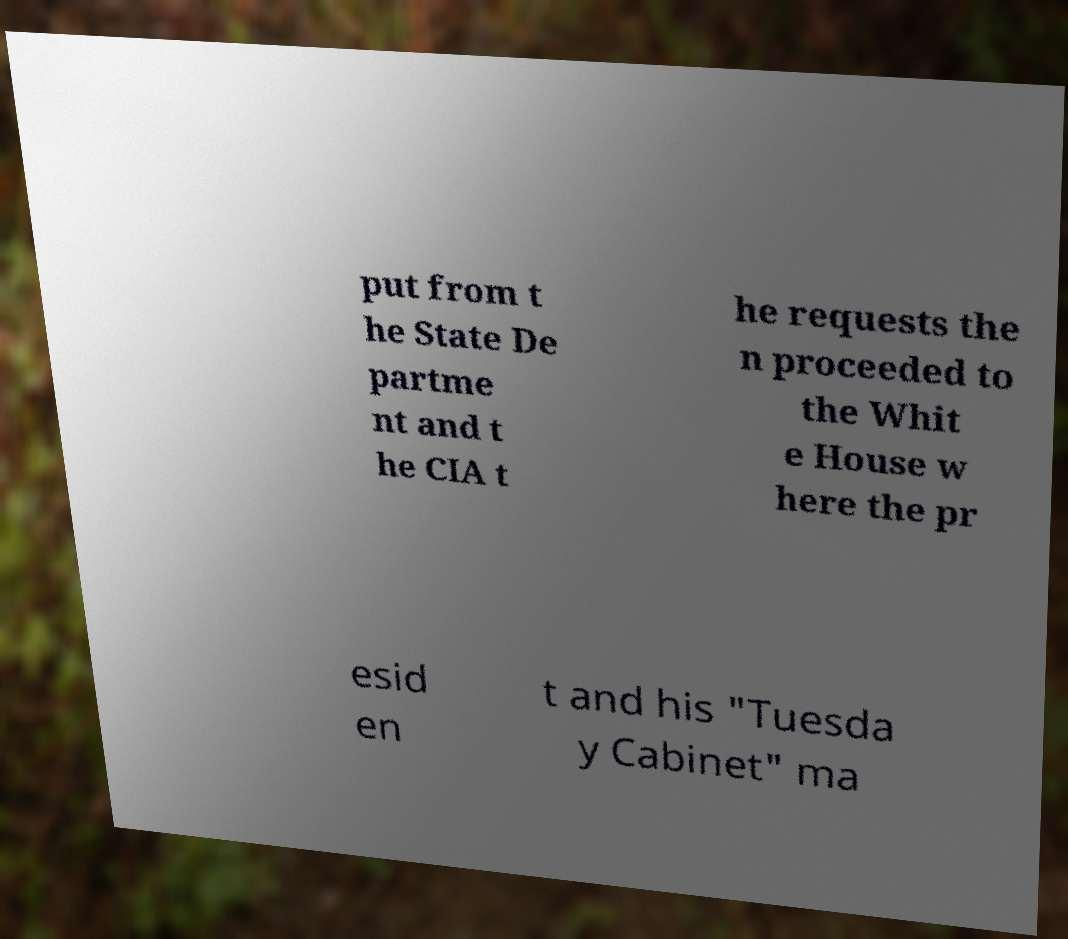Could you extract and type out the text from this image? put from t he State De partme nt and t he CIA t he requests the n proceeded to the Whit e House w here the pr esid en t and his "Tuesda y Cabinet" ma 